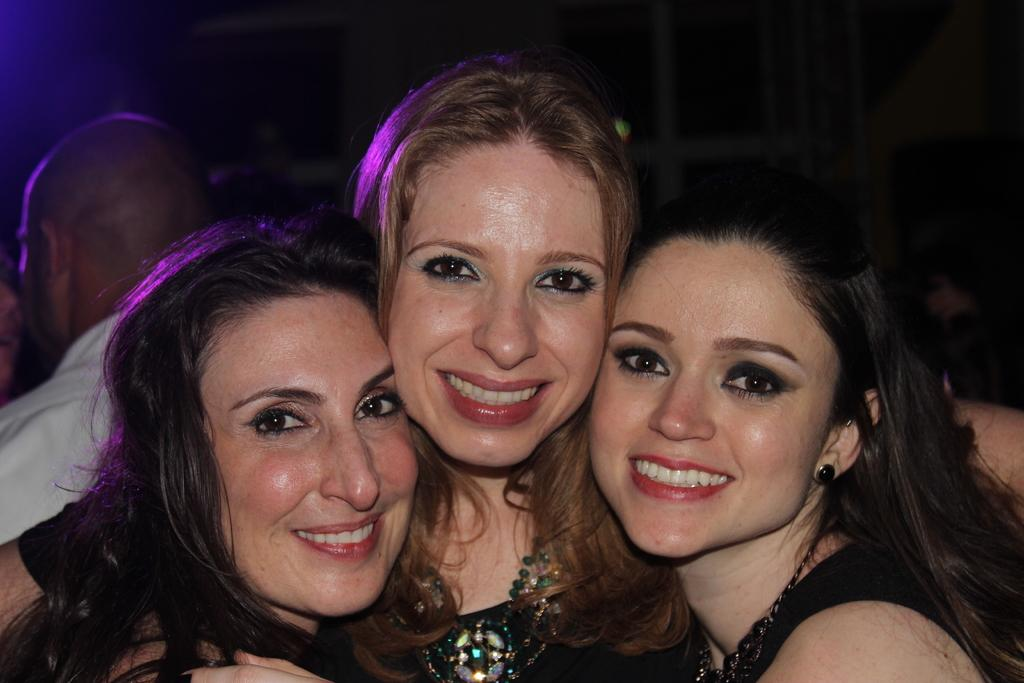How many people are in the image? There are three ladies in the image. What is the facial expression of the ladies? The ladies are smiling. Can you describe the background of the image? The background of the image is dark. Is there anyone else visible in the image besides the ladies? Yes, there is a person in the background of the image. What type of tail can be seen on the ladies in the image? There are no tails visible on the ladies in the image. What is the cause of the dark background in the image? The cause of the dark background in the image is not mentioned in the provided facts. 